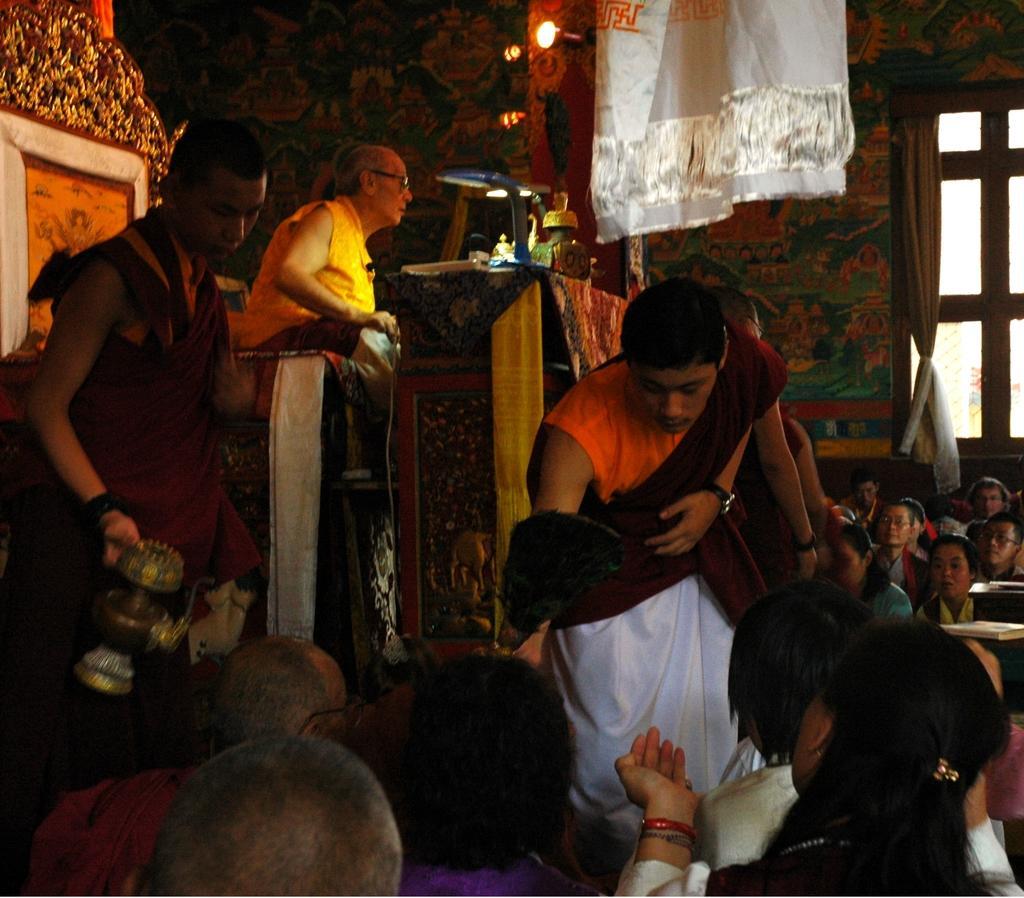In one or two sentences, can you explain what this image depicts? In this picture we can see some people are sitting and some people are standing. A person is holding an object. It looks like a person is sitting on a chair. In front of the sitting person there is a table and on the table there are some objects. Behind the people there is a light and there is a wall with a window and a curtain. 